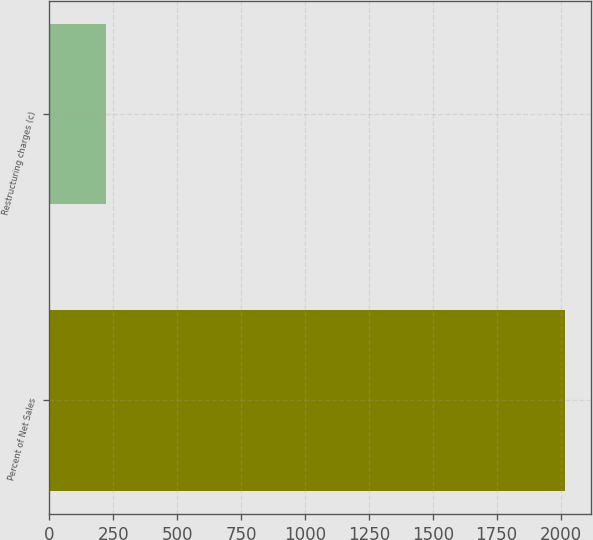Convert chart. <chart><loc_0><loc_0><loc_500><loc_500><bar_chart><fcel>Percent of Net Sales<fcel>Restructuring charges (c)<nl><fcel>2017<fcel>221.9<nl></chart> 